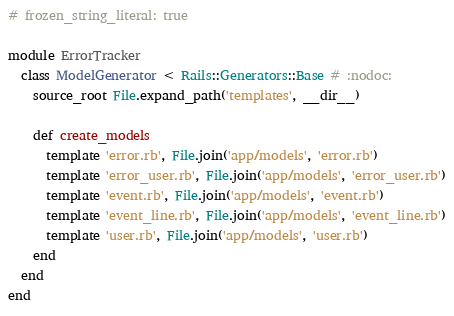<code> <loc_0><loc_0><loc_500><loc_500><_Ruby_># frozen_string_literal: true

module ErrorTracker
  class ModelGenerator < Rails::Generators::Base # :nodoc:
    source_root File.expand_path('templates', __dir__)

    def create_models
      template 'error.rb', File.join('app/models', 'error.rb')
      template 'error_user.rb', File.join('app/models', 'error_user.rb')
      template 'event.rb', File.join('app/models', 'event.rb')
      template 'event_line.rb', File.join('app/models', 'event_line.rb')
      template 'user.rb', File.join('app/models', 'user.rb')
    end
  end
end
</code> 